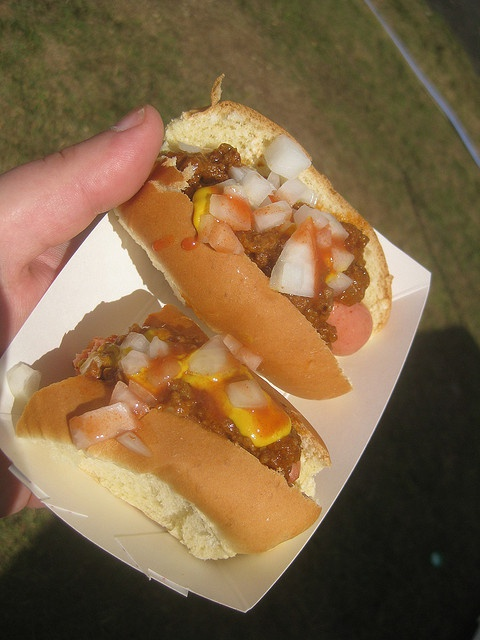Describe the objects in this image and their specific colors. I can see hot dog in black, brown, tan, and orange tones, hot dog in black, red, and tan tones, and people in black and salmon tones in this image. 